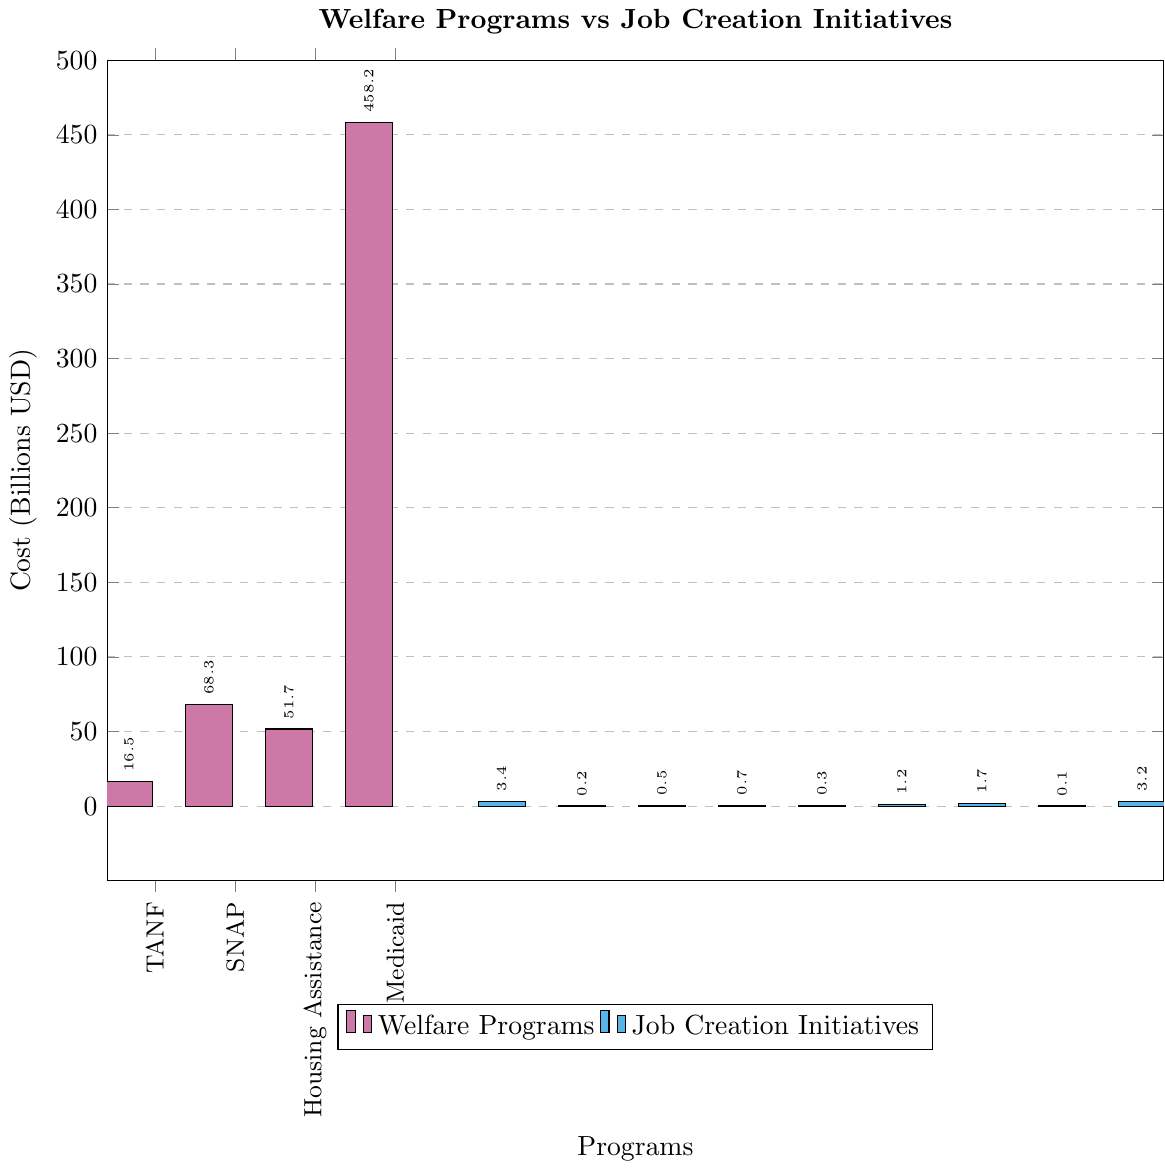Which welfare program has the highest cost? By examining the height of the bars under the welfare programs (colored in pink), the tallest bar corresponds to Medicaid.
Answer: Medicaid How much more does Medicaid cost compared to SNAP? The height of the Medicaid bar is 458.2 billion USD, and for SNAP it is 68.3 billion USD. The difference is calculated as 458.2 - 68.3.
Answer: 389.9 billion USD What is the combined cost of Job Training Programs, Job Corps, and Vocational Rehabilitation? Adding the heights of the bars for these job creation initiatives: Job Training Programs (3.4), Job Corps (1.7), and Vocational Rehabilitation (3.2). The combined cost is 3.4 + 1.7 + 3.2.
Answer: 8.3 billion USD Which job creation initiative has the lowest cost? Among the bars representing job creation initiatives (colored in blue), the smallest bar height corresponds to YouthBuild.
Answer: YouthBuild Is the total cost for welfare programs greater than the total cost for job creation initiatives? The sum of all the welfare program costs and job creation initiatives can be compared. Welfare programs: 16.5 (TANF) + 68.3 (SNAP) + 51.7 (Housing Assistance) + 458.2 (Medicaid). Job creation initiatives: 3.4 (Job Training Programs) + 0.2 (Apprenticeship Grants) + 0.5 (Workforce Innovation Fund) + 0.7 (Employment Service Grants) + 0.3 (Reemployment Services) + 1.2 (Work Opportunity Tax Credit) + 1.7 (Job Corps) + 0.1 (YouthBuild) + 3.2 (Vocational Rehabilitation). Sum the welfare programs: 16.5 + 68.3 + 51.7 + 458.2 = 594.7 billion USD. Sum the job creation initiatives: 3.4 + 0.2 + 0.5 + 0.7 + 0.3 + 1.2 + 1.7 + 0.1 + 3.2 = 11.3 billion USD. Therefore, 594.7 is greater than 11.3.
Answer: Yes How does the cost of TANF compare to Vocational Rehabilitation? The heights of the bars for TANF and Vocational Rehabilitation can be compared. TANF stands at 16.5 billion USD and Vocational Rehabilitation at 3.2 billion USD.
Answer: TANF is more expensive What is the average cost of the job creation initiatives? Sum the costs of all job creation initiatives and divide by the number of initiatives. Total cost: 3.4 + 0.2 + 0.5 + 0.7 + 0.3 + 1.2 + 1.7 + 0.1 + 3.2 = 11.3 billion USD. Number of initiatives = 9. Average = 11.3 / 9.
Answer: 1.26 billion USD If we combine the costs of SNAP and Housing Assistance, does it exceed the cost of Medicaid? Sum the costs of SNAP and Housing Assistance, then compare to Medicaid. SNAP (68.3) + Housing Assistance (51.7) = 120 billion USD. Compare 120 to 458.2 (Medicaid).
Answer: No Which program among the welfare and job creation initiatives has nearly the same cost as Job Corps? Identifying the bars that match the height of Job Corps (1.7 billion USD). The closest matches are TANF (16.5) - too high, SNAP (68.3) - too high, etc., but no exact match.
Answer: None 